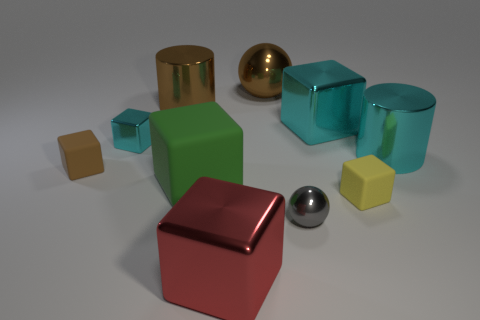The metallic thing that is on the left side of the big brown thing on the left side of the large cube that is left of the red block is what shape?
Your answer should be compact. Cube. What is the size of the brown rubber thing?
Provide a short and direct response. Small. Is there a large cube that has the same material as the small yellow cube?
Your answer should be very brief. Yes. What is the size of the yellow object that is the same shape as the red metal thing?
Offer a very short reply. Small. Are there an equal number of red metal cubes behind the large green matte cube and gray metallic blocks?
Provide a short and direct response. Yes. There is a rubber object on the right side of the small gray metal object; is it the same shape as the small cyan shiny thing?
Your answer should be very brief. Yes. What is the shape of the red metallic thing?
Give a very brief answer. Cube. The large cylinder right of the cylinder that is on the left side of the small block in front of the green object is made of what material?
Your answer should be very brief. Metal. There is a cylinder that is the same color as the big metal ball; what is its material?
Provide a short and direct response. Metal. What number of things are tiny brown matte objects or cyan blocks?
Offer a very short reply. 3. 